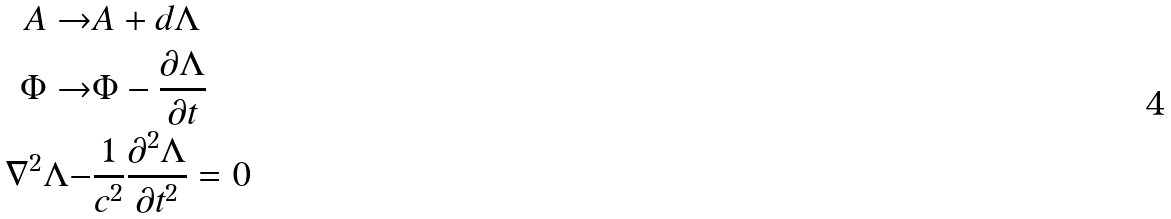<formula> <loc_0><loc_0><loc_500><loc_500>A \rightarrow & A + d \Lambda \\ \Phi \rightarrow & \Phi - \frac { \partial \Lambda } { \partial t } \\ \nabla ^ { 2 } \Lambda - & \frac { 1 } { c ^ { 2 } } \frac { \partial ^ { 2 } \Lambda } { \partial t ^ { 2 } } = 0</formula> 